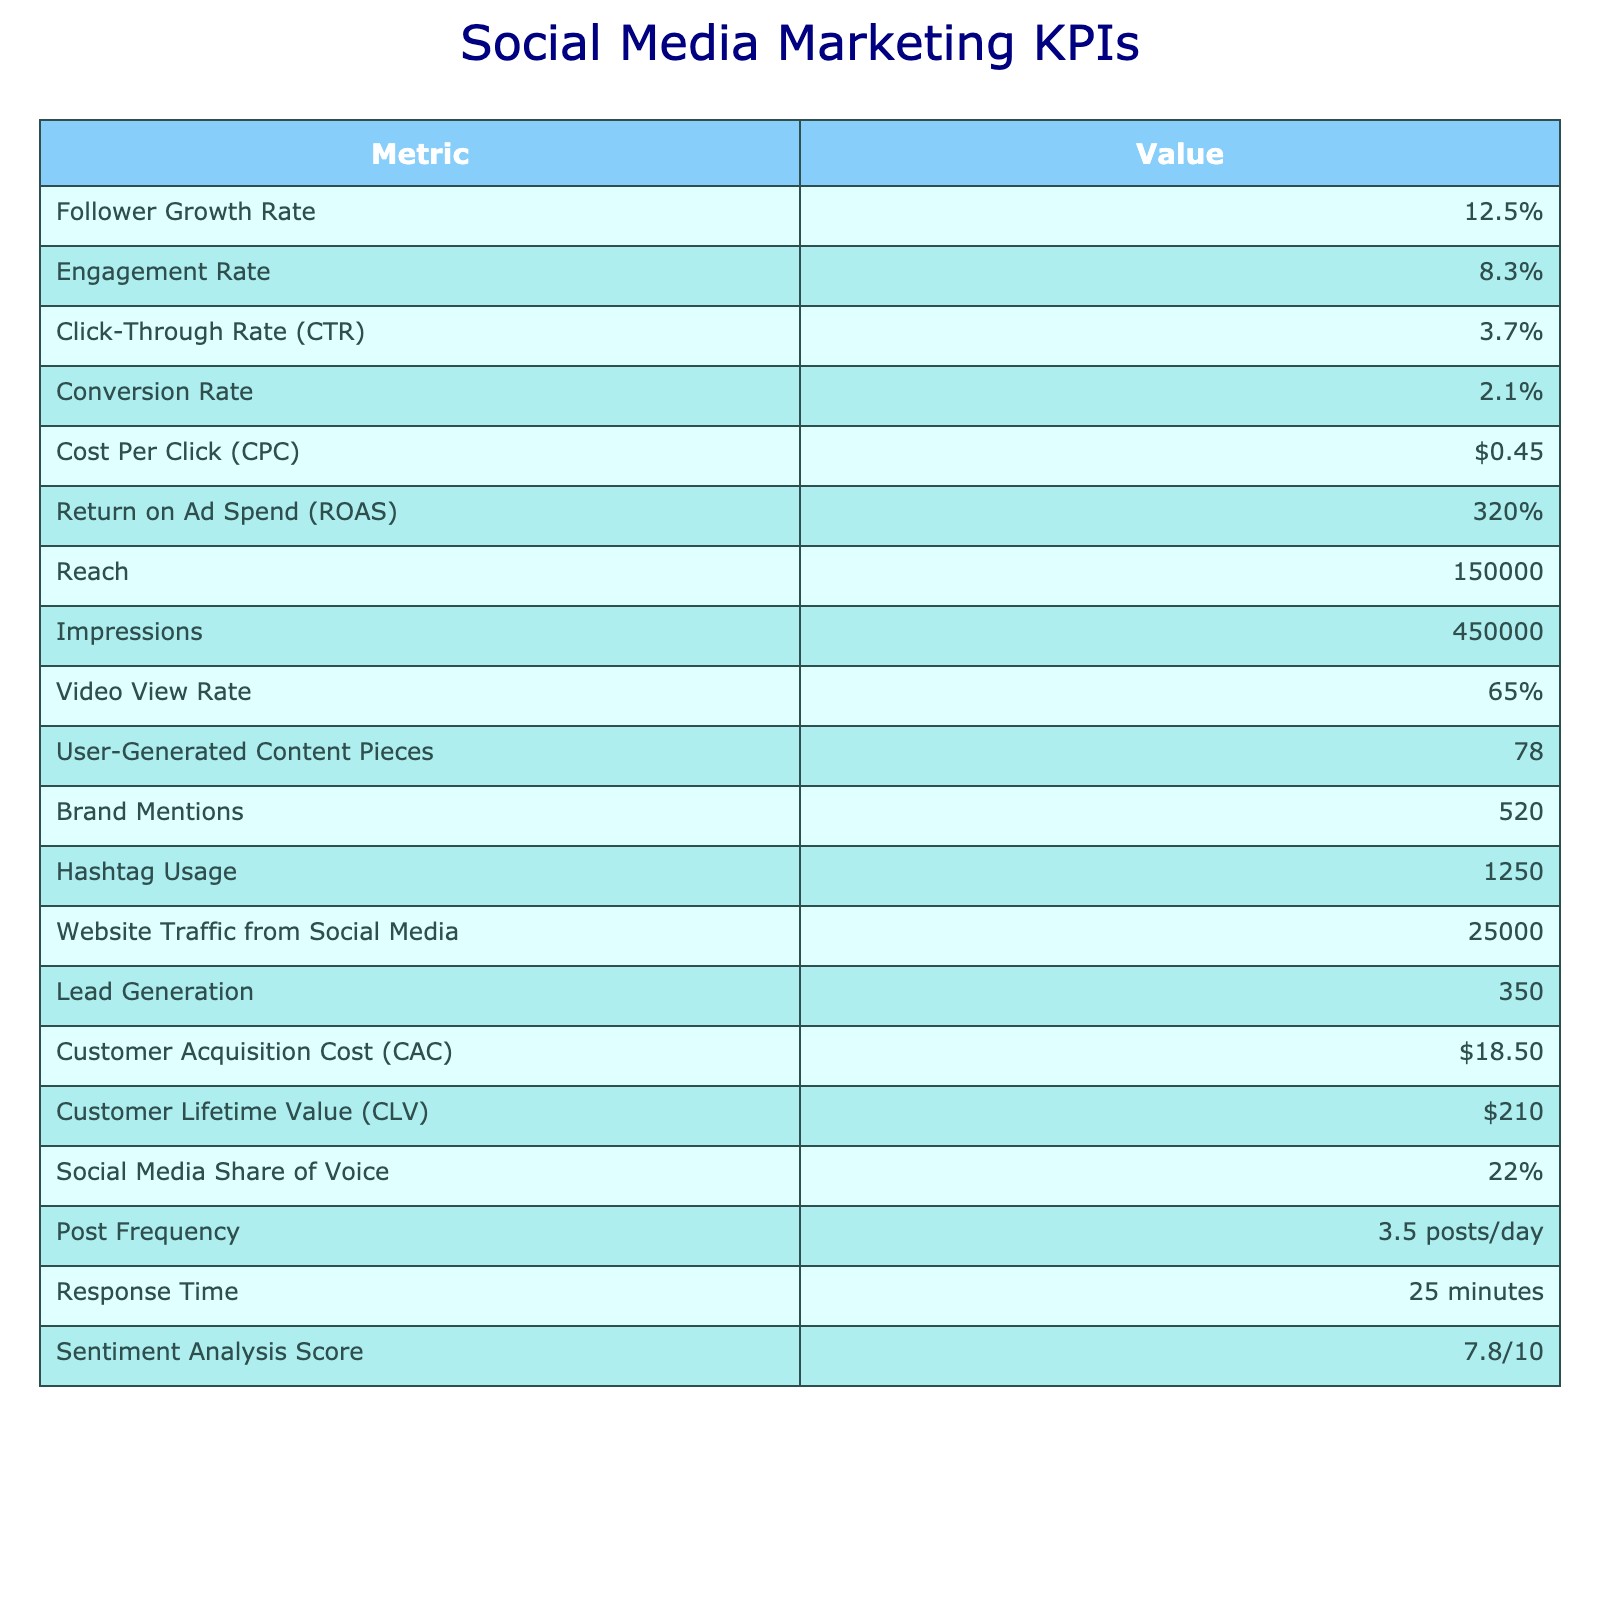What is the Follower Growth Rate? The table lists the Follower Growth Rate in the first row under "Value," which is 12.5%.
Answer: 12.5% What is the Engagement Rate? The Engagement Rate is displayed in the second row under "Value," and it shows 8.3%.
Answer: 8.3% What is the Click-Through Rate? The Click-Through Rate is found in the third row under "Value," which indicates 3.7%.
Answer: 3.7% What is the Conversion Rate? The Conversion Rate is presented in the fourth row of the table, showing a value of 2.1%.
Answer: 2.1% What is the Cost Per Click? The Cost Per Click is indicated in the fifth row under "Value," and it is $0.45.
Answer: $0.45 What is the Return on Ad Spend? The Return on Ad Spend is shown in the sixth row of the table, listed as 320%.
Answer: 320% What is the total Reach and Impressions? The Reach is listed as 150,000 and the Impressions as 450,000 in the table. The total is calculated by adding both values: 150,000 + 450,000 = 600,000.
Answer: 600,000 What is the Website Traffic from Social Media? The Website Traffic from Social Media is found in the table as 25,000 under the corresponding value.
Answer: 25,000 How many User-Generated Content Pieces were there? The number of User-Generated Content Pieces is reported in the table as 78.
Answer: 78 Is the Sentiment Analysis Score above 8? The Sentiment Analysis Score is 7.8 according to the table, which is not above 8.
Answer: No What is the difference between Customer Lifetime Value and Customer Acquisition Cost? The Customer Lifetime Value is $210, and the Customer Acquisition Cost is $18.50. The difference is calculated as $210 - $18.50, resulting in $191.50.
Answer: $191.50 Is the Engagement Rate higher than the Click-Through Rate? The Engagement Rate is 8.3%, and the Click-Through Rate is 3.7%. Since 8.3% is greater than 3.7%, the statement is true.
Answer: Yes What percentage of Brand Mentions relate to the Total Impressions? There are 520 Brand Mentions and 450,000 Total Impressions. The percentage is calculated as (520 / 450,000) * 100, which is approximately 0.115%.
Answer: 0.115% If the Post Frequency is 3.5 posts per day, how many posts are made in a month? To find the total monthly posts, multiply the Post Frequency by the number of days in a month: 3.5 posts/day * 30 days = 105 posts/month.
Answer: 105 What is the ratio of Reach to Website Traffic from Social Media? The Reach is 150,000 and the Website Traffic from Social Media is 25,000. The ratio is calculated as Reach / Website Traffic, which is 150,000 / 25,000 = 6.
Answer: 6 